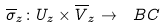<formula> <loc_0><loc_0><loc_500><loc_500>\overline { \sigma } _ { z } \colon U _ { z } \times \overline { V } _ { z } \to \ B C</formula> 